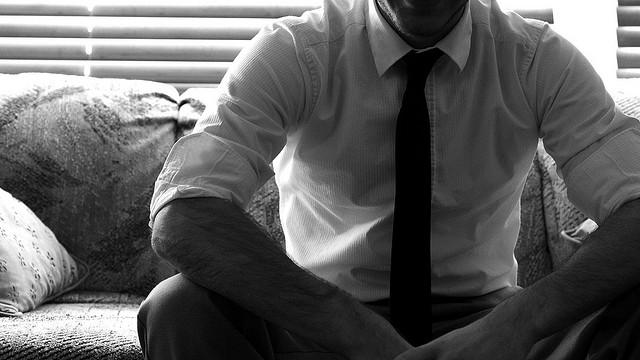What is the man sitting on?
Write a very short answer. Couch. What is the man wearing around his neck?
Short answer required. Tie. Does the man have any tattoos showing?
Quick response, please. No. 